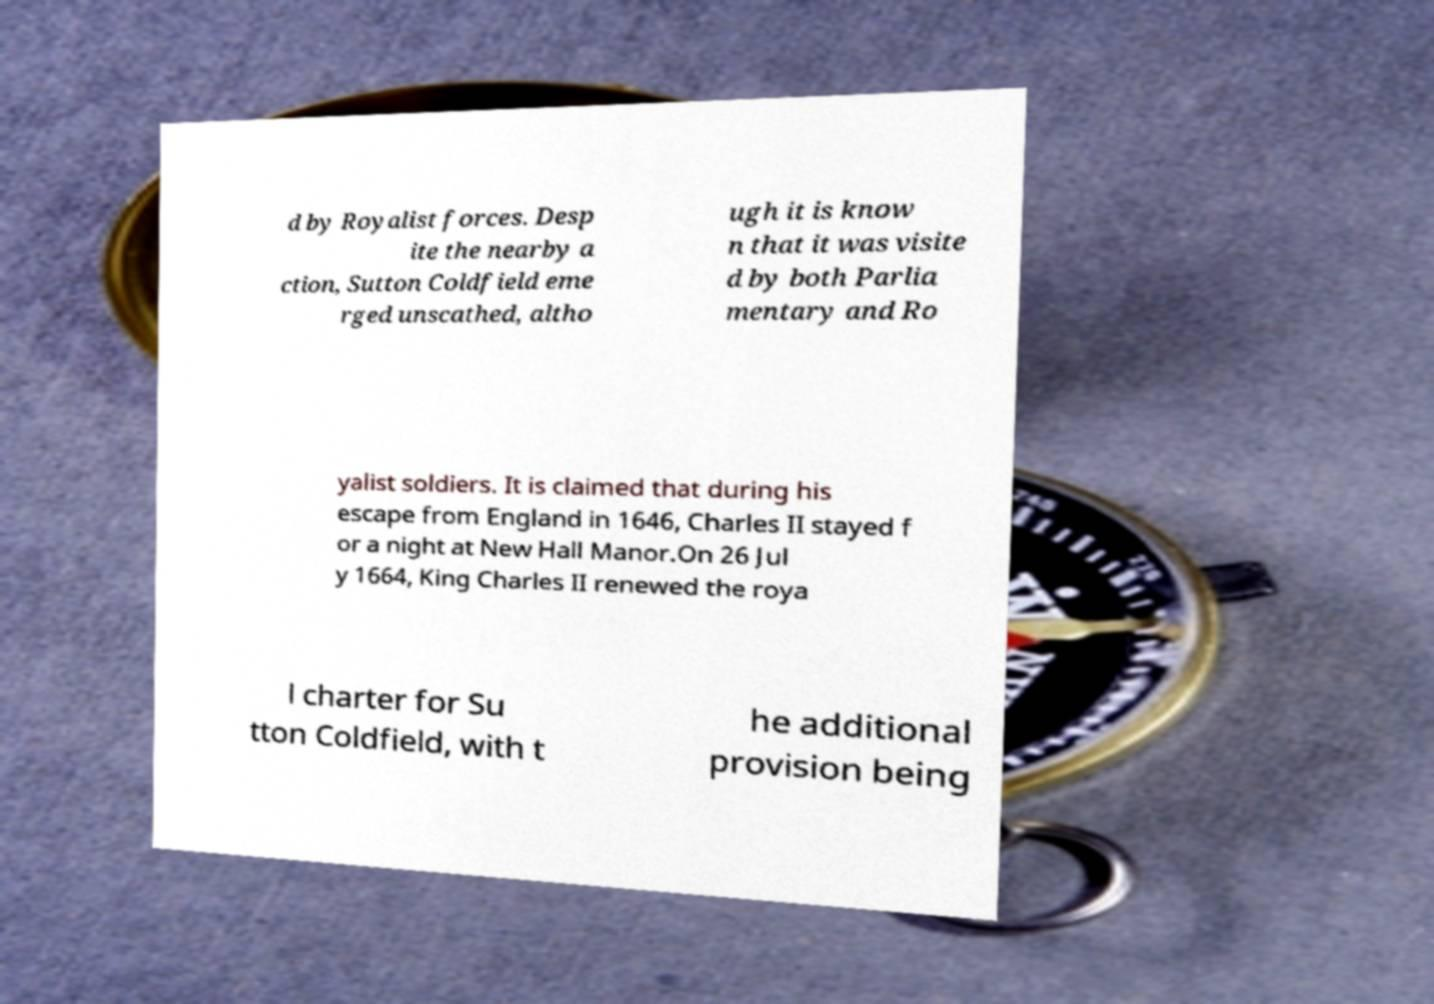What messages or text are displayed in this image? I need them in a readable, typed format. d by Royalist forces. Desp ite the nearby a ction, Sutton Coldfield eme rged unscathed, altho ugh it is know n that it was visite d by both Parlia mentary and Ro yalist soldiers. It is claimed that during his escape from England in 1646, Charles II stayed f or a night at New Hall Manor.On 26 Jul y 1664, King Charles II renewed the roya l charter for Su tton Coldfield, with t he additional provision being 